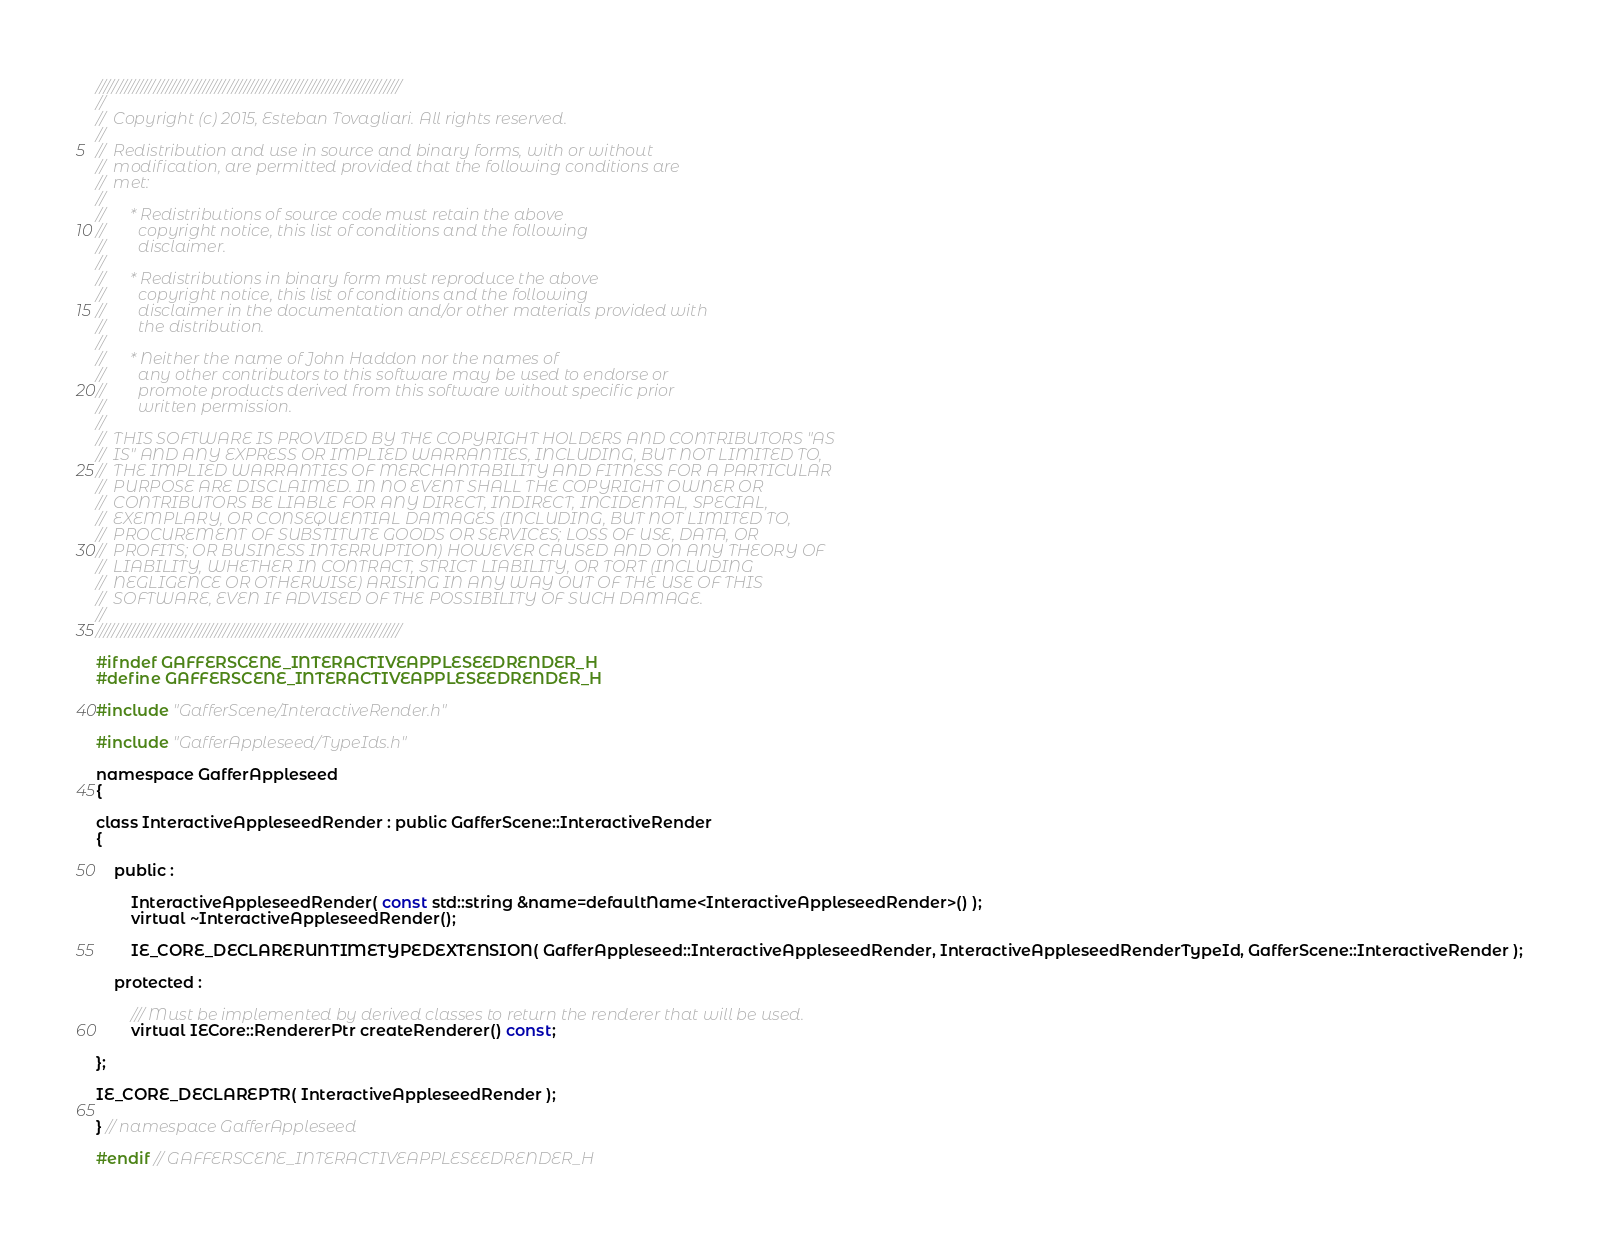<code> <loc_0><loc_0><loc_500><loc_500><_C_>//////////////////////////////////////////////////////////////////////////
//
//  Copyright (c) 2015, Esteban Tovagliari. All rights reserved.
//
//  Redistribution and use in source and binary forms, with or without
//  modification, are permitted provided that the following conditions are
//  met:
//
//      * Redistributions of source code must retain the above
//        copyright notice, this list of conditions and the following
//        disclaimer.
//
//      * Redistributions in binary form must reproduce the above
//        copyright notice, this list of conditions and the following
//        disclaimer in the documentation and/or other materials provided with
//        the distribution.
//
//      * Neither the name of John Haddon nor the names of
//        any other contributors to this software may be used to endorse or
//        promote products derived from this software without specific prior
//        written permission.
//
//  THIS SOFTWARE IS PROVIDED BY THE COPYRIGHT HOLDERS AND CONTRIBUTORS "AS
//  IS" AND ANY EXPRESS OR IMPLIED WARRANTIES, INCLUDING, BUT NOT LIMITED TO,
//  THE IMPLIED WARRANTIES OF MERCHANTABILITY AND FITNESS FOR A PARTICULAR
//  PURPOSE ARE DISCLAIMED. IN NO EVENT SHALL THE COPYRIGHT OWNER OR
//  CONTRIBUTORS BE LIABLE FOR ANY DIRECT, INDIRECT, INCIDENTAL, SPECIAL,
//  EXEMPLARY, OR CONSEQUENTIAL DAMAGES (INCLUDING, BUT NOT LIMITED TO,
//  PROCUREMENT OF SUBSTITUTE GOODS OR SERVICES; LOSS OF USE, DATA, OR
//  PROFITS; OR BUSINESS INTERRUPTION) HOWEVER CAUSED AND ON ANY THEORY OF
//  LIABILITY, WHETHER IN CONTRACT, STRICT LIABILITY, OR TORT (INCLUDING
//  NEGLIGENCE OR OTHERWISE) ARISING IN ANY WAY OUT OF THE USE OF THIS
//  SOFTWARE, EVEN IF ADVISED OF THE POSSIBILITY OF SUCH DAMAGE.
//
//////////////////////////////////////////////////////////////////////////

#ifndef GAFFERSCENE_INTERACTIVEAPPLESEEDRENDER_H
#define GAFFERSCENE_INTERACTIVEAPPLESEEDRENDER_H

#include "GafferScene/InteractiveRender.h"

#include "GafferAppleseed/TypeIds.h"

namespace GafferAppleseed
{

class InteractiveAppleseedRender : public GafferScene::InteractiveRender
{

	public :

		InteractiveAppleseedRender( const std::string &name=defaultName<InteractiveAppleseedRender>() );
		virtual ~InteractiveAppleseedRender();

		IE_CORE_DECLARERUNTIMETYPEDEXTENSION( GafferAppleseed::InteractiveAppleseedRender, InteractiveAppleseedRenderTypeId, GafferScene::InteractiveRender );

	protected :

		/// Must be implemented by derived classes to return the renderer that will be used.
		virtual IECore::RendererPtr createRenderer() const;

};

IE_CORE_DECLAREPTR( InteractiveAppleseedRender );

} // namespace GafferAppleseed

#endif // GAFFERSCENE_INTERACTIVEAPPLESEEDRENDER_H
</code> 